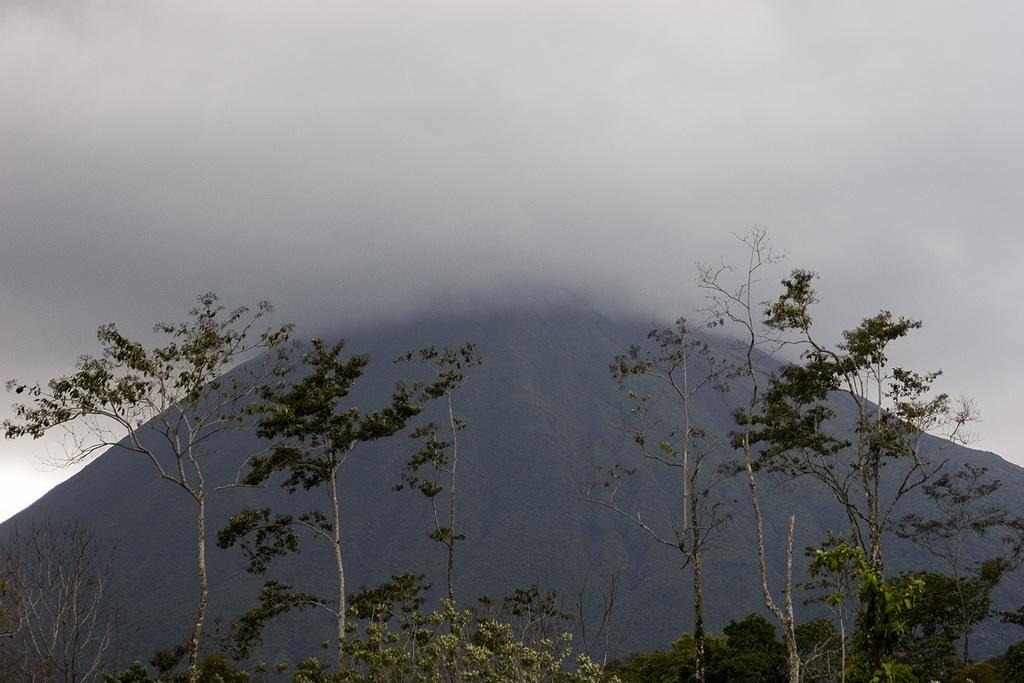What type of vegetation is at the bottom of the image? There are trees at the bottom of the image. What geographical feature can be seen in the background of the image? There is a hill visible in the background of the image. What is visible at the top of the image? The sky is visible at the top of the image. How does the existence of the trees affect the increase in the veil's transparency in the image? There is no mention of a veil in the image, so it is not possible to determine how the trees might affect its transparency. 